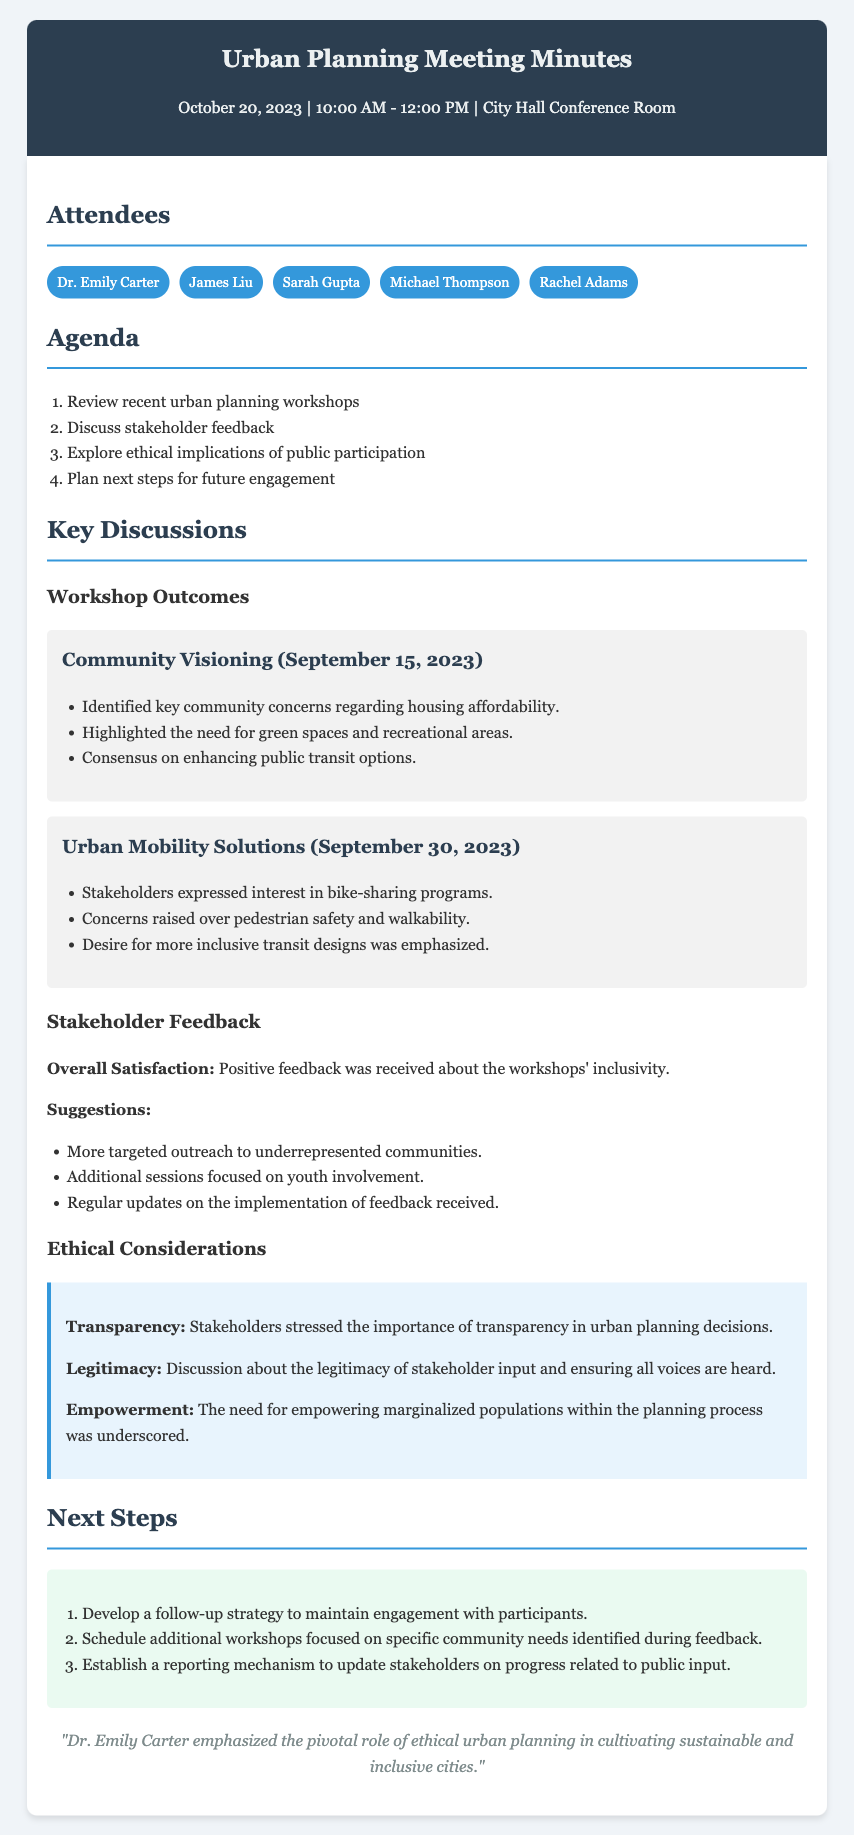What date was the meeting held? The meeting was held on October 20, 2023, as mentioned in the header.
Answer: October 20, 2023 Who is one of the attendees? The attendees are listed in the document, and Dr. Emily Carter is one of them.
Answer: Dr. Emily Carter What was one key community concern identified in the Community Visioning workshop? The document states housing affordability as a key community concern from the workshop.
Answer: Housing affordability What suggestion was made regarding outreach? One suggestion was for more targeted outreach to underrepresented communities, as listed under Stakeholder Feedback.
Answer: More targeted outreach to underrepresented communities What is one ethical consideration discussed? Transparency is highlighted as an important ethical consideration in the document.
Answer: Transparency How many workshops are mentioned in the document? Two workshops were discussed: Community Visioning and Urban Mobility Solutions.
Answer: Two What is a next step outlined in the meeting? Developing a follow-up strategy to maintain engagement is one of the next steps listed.
Answer: Develop a follow-up strategy What type of feedback was received regarding the workshops' inclusivity? The feedback received was positive regarding inclusivity, as stated in the Stakeholder Feedback section.
Answer: Positive Who emphasized the role of ethical urban planning? Dr. Emily Carter emphasized the pivotal role, according to the closing remarks.
Answer: Dr. Emily Carter 